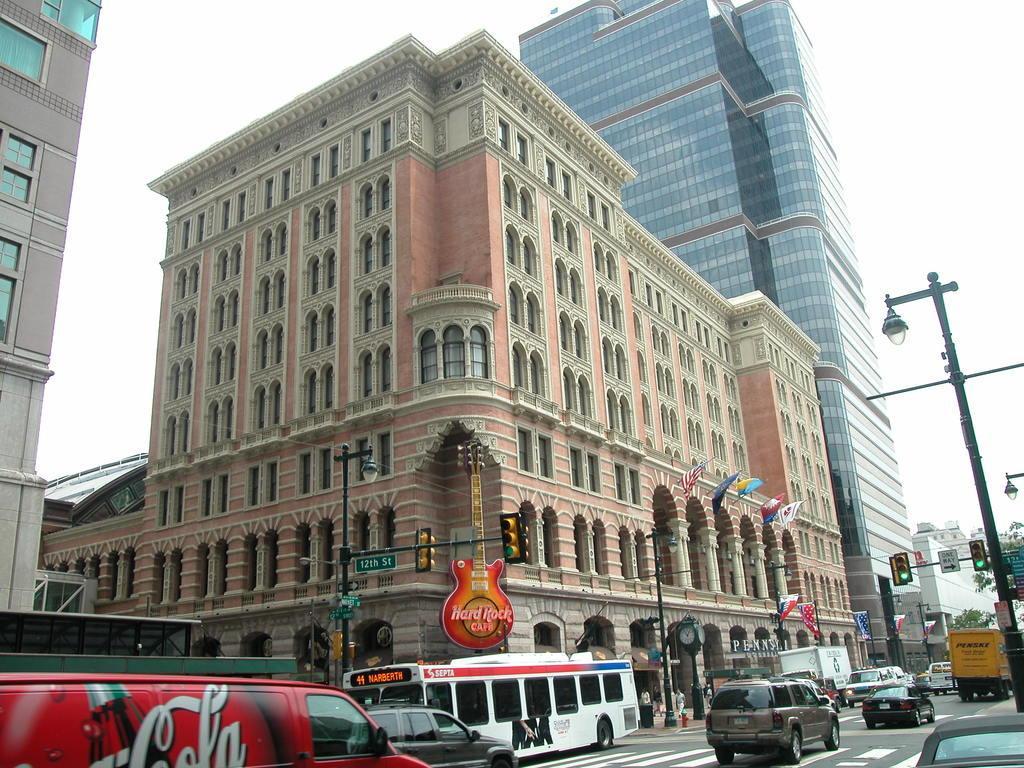What can be seen on the road in the image? There are vehicles on the road in the image. What is visible in the background of the image? There are buildings, poles, boards, flags, traffic lights, trees, and people in the background of the image. What is visible at the top of the image? The sky is visible at the top of the image. Can you tell me how many beggars are present in the image? There is no mention of a beggar in the image; it features vehicles on the road and various elements in the background. What unit of measurement is used to determine the height of the trees in the image? There is no information provided about measuring the height of the trees in the image, nor is there any mention of a unit of measurement. 